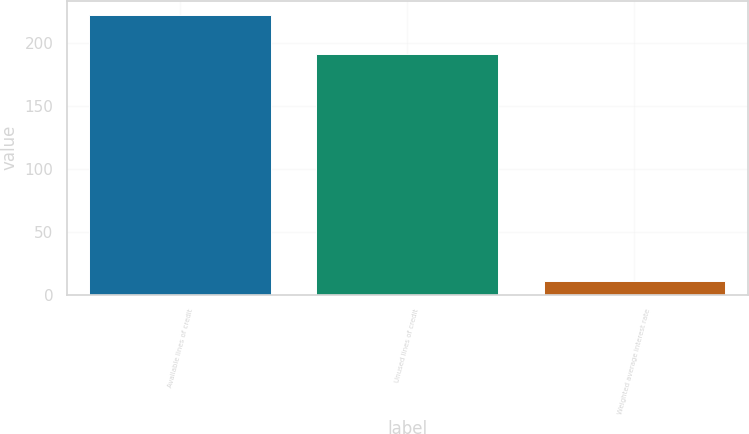<chart> <loc_0><loc_0><loc_500><loc_500><bar_chart><fcel>Available lines of credit<fcel>Unused lines of credit<fcel>Weighted average interest rate<nl><fcel>222.2<fcel>191.1<fcel>11.2<nl></chart> 